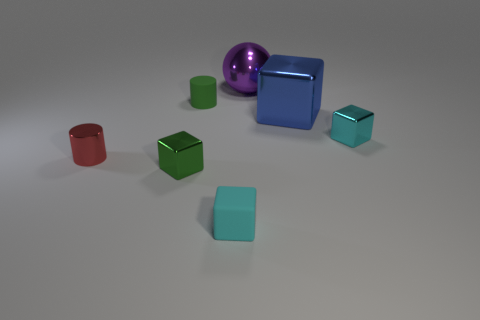Add 2 blue cubes. How many objects exist? 9 Subtract all balls. How many objects are left? 6 Subtract all tiny metal things. Subtract all large metal blocks. How many objects are left? 3 Add 4 purple shiny balls. How many purple shiny balls are left? 5 Add 4 purple balls. How many purple balls exist? 5 Subtract 1 purple spheres. How many objects are left? 6 